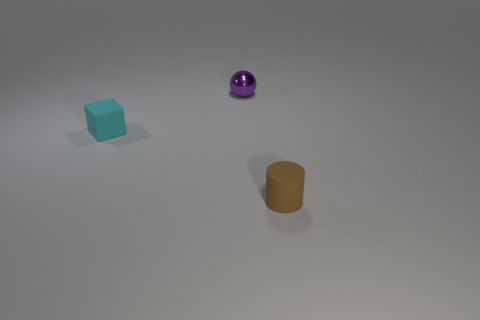Add 3 small purple shiny balls. How many objects exist? 6 Subtract all balls. How many objects are left? 2 Add 3 tiny matte blocks. How many tiny matte blocks exist? 4 Subtract 0 blue spheres. How many objects are left? 3 Subtract all cyan objects. Subtract all tiny rubber objects. How many objects are left? 0 Add 1 brown things. How many brown things are left? 2 